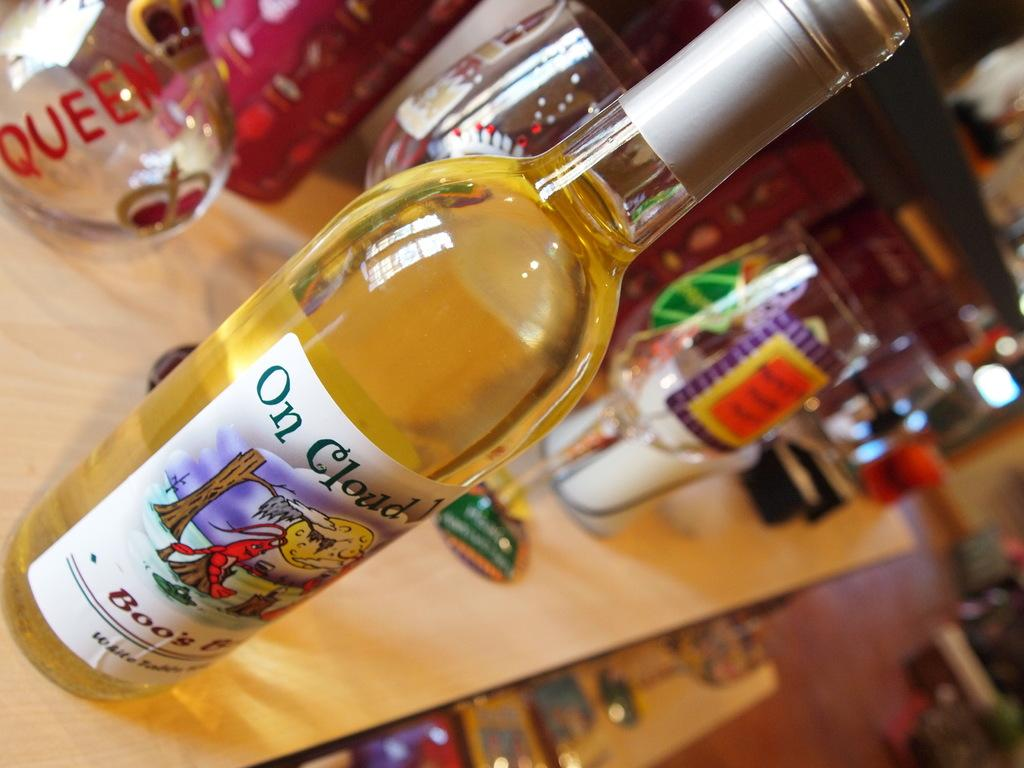What is on the table in the image? There is a bottle and glasses on the table in the image. What is the surface beneath the table? The table is on a floor. What type of coil is wrapped around the bottle in the image? There is no coil wrapped around the bottle in the image. What color is the yarn used to decorate the glasses in the image? There is no yarn used to decorate the glasses in the image. 